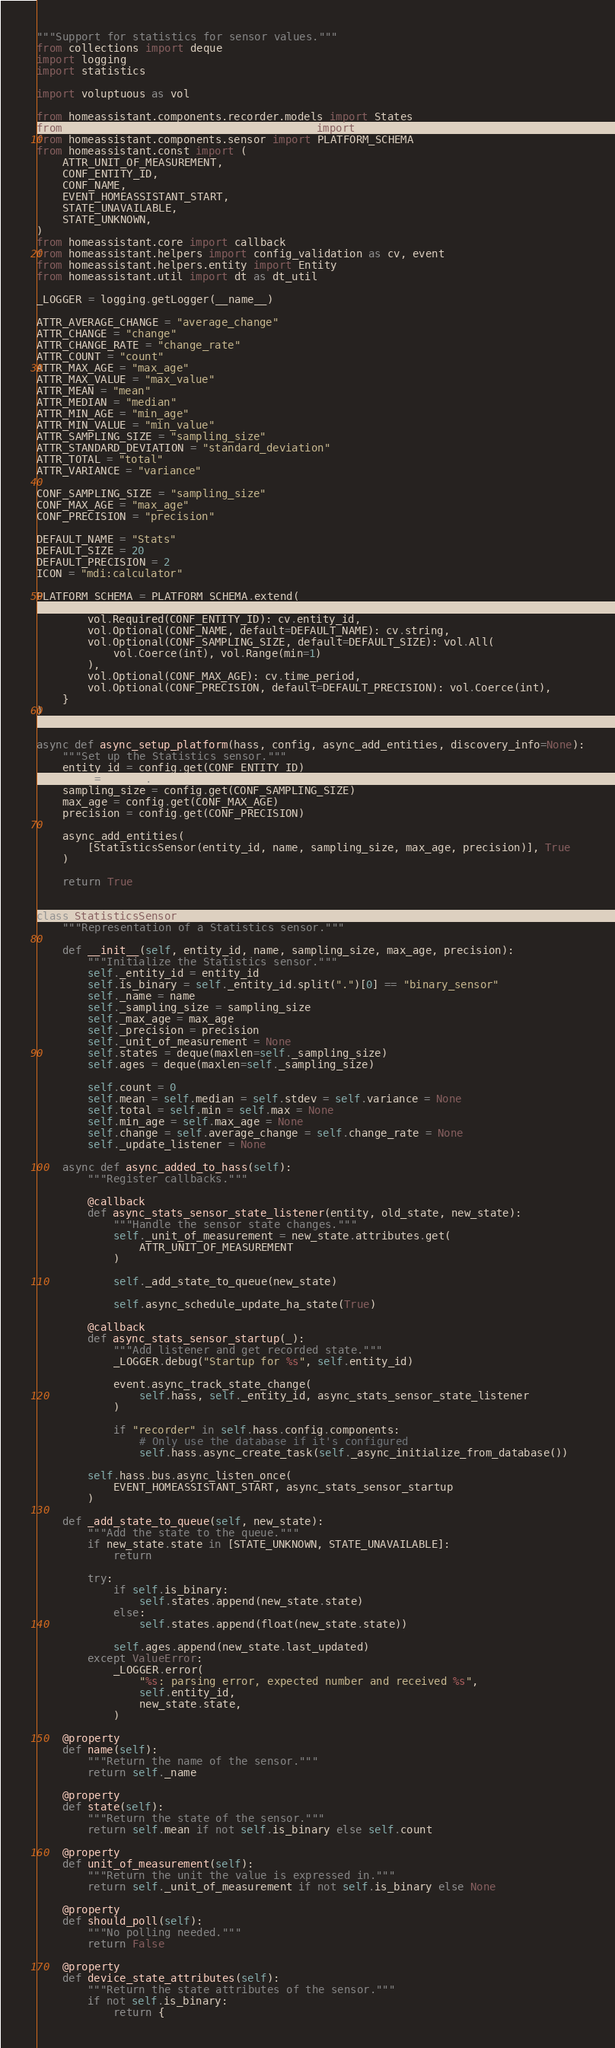<code> <loc_0><loc_0><loc_500><loc_500><_Python_>"""Support for statistics for sensor values."""
from collections import deque
import logging
import statistics

import voluptuous as vol

from homeassistant.components.recorder.models import States
from homeassistant.components.recorder.util import execute, session_scope
from homeassistant.components.sensor import PLATFORM_SCHEMA
from homeassistant.const import (
    ATTR_UNIT_OF_MEASUREMENT,
    CONF_ENTITY_ID,
    CONF_NAME,
    EVENT_HOMEASSISTANT_START,
    STATE_UNAVAILABLE,
    STATE_UNKNOWN,
)
from homeassistant.core import callback
from homeassistant.helpers import config_validation as cv, event
from homeassistant.helpers.entity import Entity
from homeassistant.util import dt as dt_util

_LOGGER = logging.getLogger(__name__)

ATTR_AVERAGE_CHANGE = "average_change"
ATTR_CHANGE = "change"
ATTR_CHANGE_RATE = "change_rate"
ATTR_COUNT = "count"
ATTR_MAX_AGE = "max_age"
ATTR_MAX_VALUE = "max_value"
ATTR_MEAN = "mean"
ATTR_MEDIAN = "median"
ATTR_MIN_AGE = "min_age"
ATTR_MIN_VALUE = "min_value"
ATTR_SAMPLING_SIZE = "sampling_size"
ATTR_STANDARD_DEVIATION = "standard_deviation"
ATTR_TOTAL = "total"
ATTR_VARIANCE = "variance"

CONF_SAMPLING_SIZE = "sampling_size"
CONF_MAX_AGE = "max_age"
CONF_PRECISION = "precision"

DEFAULT_NAME = "Stats"
DEFAULT_SIZE = 20
DEFAULT_PRECISION = 2
ICON = "mdi:calculator"

PLATFORM_SCHEMA = PLATFORM_SCHEMA.extend(
    {
        vol.Required(CONF_ENTITY_ID): cv.entity_id,
        vol.Optional(CONF_NAME, default=DEFAULT_NAME): cv.string,
        vol.Optional(CONF_SAMPLING_SIZE, default=DEFAULT_SIZE): vol.All(
            vol.Coerce(int), vol.Range(min=1)
        ),
        vol.Optional(CONF_MAX_AGE): cv.time_period,
        vol.Optional(CONF_PRECISION, default=DEFAULT_PRECISION): vol.Coerce(int),
    }
)


async def async_setup_platform(hass, config, async_add_entities, discovery_info=None):
    """Set up the Statistics sensor."""
    entity_id = config.get(CONF_ENTITY_ID)
    name = config.get(CONF_NAME)
    sampling_size = config.get(CONF_SAMPLING_SIZE)
    max_age = config.get(CONF_MAX_AGE)
    precision = config.get(CONF_PRECISION)

    async_add_entities(
        [StatisticsSensor(entity_id, name, sampling_size, max_age, precision)], True
    )

    return True


class StatisticsSensor(Entity):
    """Representation of a Statistics sensor."""

    def __init__(self, entity_id, name, sampling_size, max_age, precision):
        """Initialize the Statistics sensor."""
        self._entity_id = entity_id
        self.is_binary = self._entity_id.split(".")[0] == "binary_sensor"
        self._name = name
        self._sampling_size = sampling_size
        self._max_age = max_age
        self._precision = precision
        self._unit_of_measurement = None
        self.states = deque(maxlen=self._sampling_size)
        self.ages = deque(maxlen=self._sampling_size)

        self.count = 0
        self.mean = self.median = self.stdev = self.variance = None
        self.total = self.min = self.max = None
        self.min_age = self.max_age = None
        self.change = self.average_change = self.change_rate = None
        self._update_listener = None

    async def async_added_to_hass(self):
        """Register callbacks."""

        @callback
        def async_stats_sensor_state_listener(entity, old_state, new_state):
            """Handle the sensor state changes."""
            self._unit_of_measurement = new_state.attributes.get(
                ATTR_UNIT_OF_MEASUREMENT
            )

            self._add_state_to_queue(new_state)

            self.async_schedule_update_ha_state(True)

        @callback
        def async_stats_sensor_startup(_):
            """Add listener and get recorded state."""
            _LOGGER.debug("Startup for %s", self.entity_id)

            event.async_track_state_change(
                self.hass, self._entity_id, async_stats_sensor_state_listener
            )

            if "recorder" in self.hass.config.components:
                # Only use the database if it's configured
                self.hass.async_create_task(self._async_initialize_from_database())

        self.hass.bus.async_listen_once(
            EVENT_HOMEASSISTANT_START, async_stats_sensor_startup
        )

    def _add_state_to_queue(self, new_state):
        """Add the state to the queue."""
        if new_state.state in [STATE_UNKNOWN, STATE_UNAVAILABLE]:
            return

        try:
            if self.is_binary:
                self.states.append(new_state.state)
            else:
                self.states.append(float(new_state.state))

            self.ages.append(new_state.last_updated)
        except ValueError:
            _LOGGER.error(
                "%s: parsing error, expected number and received %s",
                self.entity_id,
                new_state.state,
            )

    @property
    def name(self):
        """Return the name of the sensor."""
        return self._name

    @property
    def state(self):
        """Return the state of the sensor."""
        return self.mean if not self.is_binary else self.count

    @property
    def unit_of_measurement(self):
        """Return the unit the value is expressed in."""
        return self._unit_of_measurement if not self.is_binary else None

    @property
    def should_poll(self):
        """No polling needed."""
        return False

    @property
    def device_state_attributes(self):
        """Return the state attributes of the sensor."""
        if not self.is_binary:
            return {</code> 